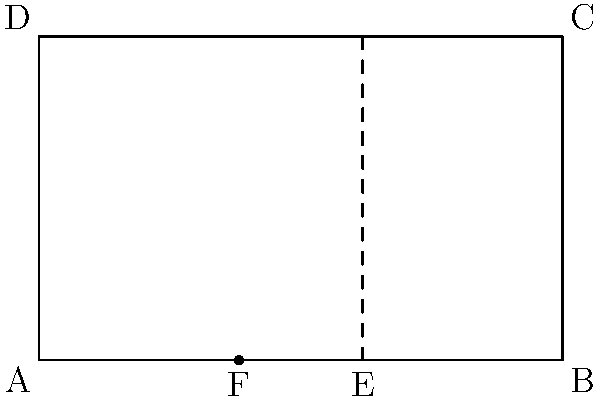In the context of exploring the golden ratio in art, consider the rectangle ABCD where AB = 1.618 and AD = 1. Point E divides AB such that AE = 1. How does the placement of point F, which divides AB into the golden ratio, relate to the aesthetic principles often found in artistic compositions? What psychological impact might this have on viewers? To understand the golden ratio's impact on artistic composition and its psychological effects, let's break down the problem:

1. The golden ratio, approximately 1.618, is represented by the Greek letter φ (phi).

2. In the rectangle ABCD:
   AB = 1.618 (φ)
   AD = 1

3. Point E divides AB such that AE = 1 and EB = 0.618

4. The golden ratio states that a line segment is divided into two parts where the ratio of the whole segment to the longer part equals the ratio of the longer part to the shorter part.

5. Mathematically, this is expressed as:
   $\frac{a+b}{a} = \frac{a}{b} = φ ≈ 1.618$

6. Point F divides AB according to the golden ratio:
   AF : FB = AB : AF
   $\frac{AF}{FB} = \frac{AB}{AF} = φ$

7. This means AF ≈ 1 and FB ≈ 0.618

8. The placement of F creates a visually pleasing division of space, often subconsciously perceived as balanced and harmonious.

9. Psychologically, this ratio is believed to be inherently attractive to the human eye, creating a sense of natural beauty and proportion.

10. Artists and designers often use this ratio to create compositions that feel balanced, dynamic, and aesthetically pleasing.

11. The psychological impact on viewers may include:
    - A sense of harmony and balance
    - Increased visual interest and engagement
    - A subconscious feeling of "rightness" or satisfaction
    - Enhanced perception of beauty and sophistication in the artwork

12. As a psychologist, you might consider how this innate attraction to the golden ratio reflects deeper cognitive processes or evolutionary adaptations in human perception.
Answer: The golden ratio creates visually pleasing proportions, potentially inducing feelings of harmony, balance, and aesthetic satisfaction in viewers. 